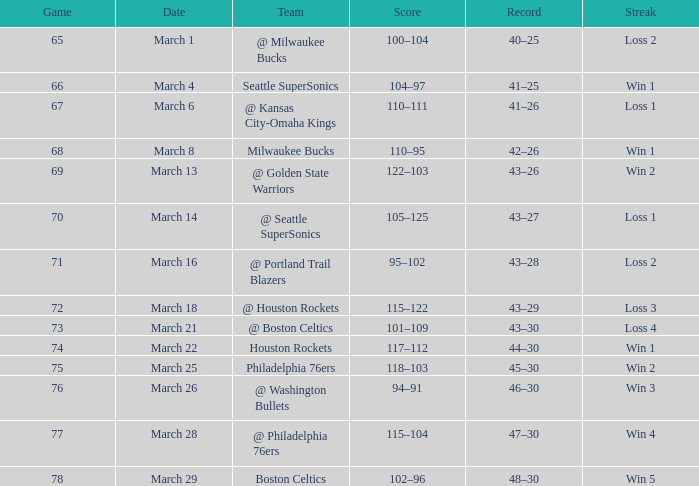What is Team, when Game is 73? @ Boston Celtics. Would you mind parsing the complete table? {'header': ['Game', 'Date', 'Team', 'Score', 'Record', 'Streak'], 'rows': [['65', 'March 1', '@ Milwaukee Bucks', '100–104', '40–25', 'Loss 2'], ['66', 'March 4', 'Seattle SuperSonics', '104–97', '41–25', 'Win 1'], ['67', 'March 6', '@ Kansas City-Omaha Kings', '110–111', '41–26', 'Loss 1'], ['68', 'March 8', 'Milwaukee Bucks', '110–95', '42–26', 'Win 1'], ['69', 'March 13', '@ Golden State Warriors', '122–103', '43–26', 'Win 2'], ['70', 'March 14', '@ Seattle SuperSonics', '105–125', '43–27', 'Loss 1'], ['71', 'March 16', '@ Portland Trail Blazers', '95–102', '43–28', 'Loss 2'], ['72', 'March 18', '@ Houston Rockets', '115–122', '43–29', 'Loss 3'], ['73', 'March 21', '@ Boston Celtics', '101–109', '43–30', 'Loss 4'], ['74', 'March 22', 'Houston Rockets', '117–112', '44–30', 'Win 1'], ['75', 'March 25', 'Philadelphia 76ers', '118–103', '45–30', 'Win 2'], ['76', 'March 26', '@ Washington Bullets', '94–91', '46–30', 'Win 3'], ['77', 'March 28', '@ Philadelphia 76ers', '115–104', '47–30', 'Win 4'], ['78', 'March 29', 'Boston Celtics', '102–96', '48–30', 'Win 5']]} 